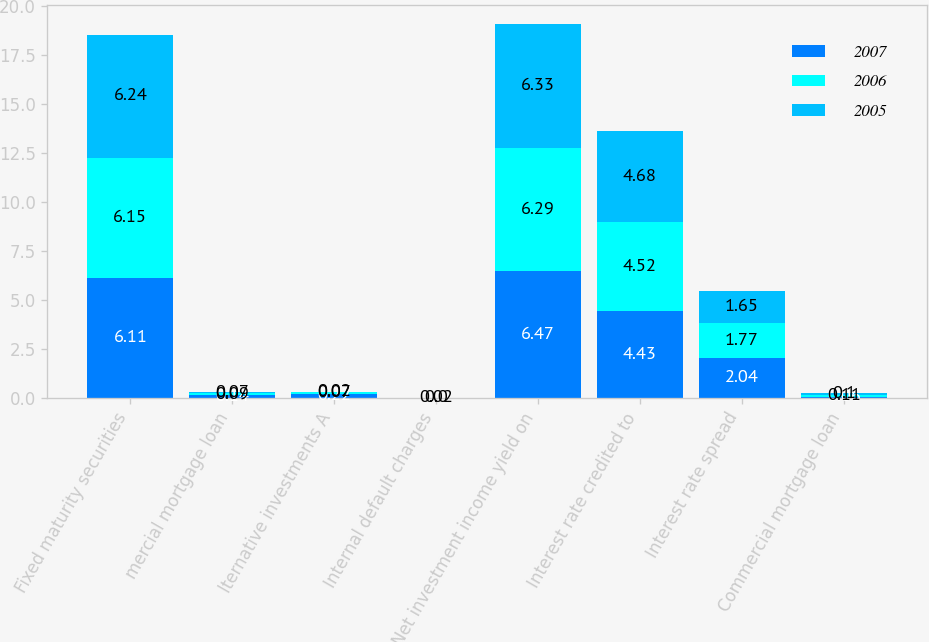Convert chart. <chart><loc_0><loc_0><loc_500><loc_500><stacked_bar_chart><ecel><fcel>Fixed maturity securities<fcel>mercial mortgage loan<fcel>lternative investments A<fcel>Internal default charges<fcel>Net investment income yield on<fcel>Interest rate credited to<fcel>Interest rate spread<fcel>Commercial mortgage loan<nl><fcel>2007<fcel>6.11<fcel>0.14<fcel>0.22<fcel>0<fcel>6.47<fcel>4.43<fcel>2.04<fcel>0.06<nl><fcel>2006<fcel>6.15<fcel>0.09<fcel>0.07<fcel>0.02<fcel>6.29<fcel>4.52<fcel>1.77<fcel>0.11<nl><fcel>2005<fcel>6.24<fcel>0.07<fcel>0.02<fcel>0<fcel>6.33<fcel>4.68<fcel>1.65<fcel>0.1<nl></chart> 